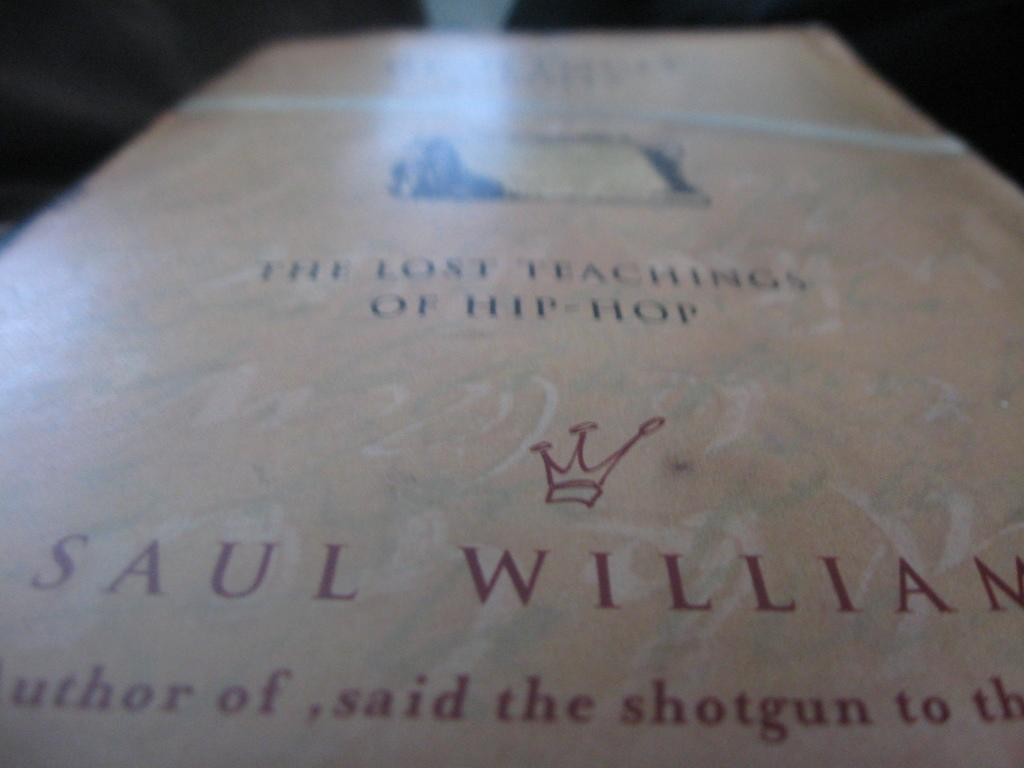<image>
Summarize the visual content of the image. The Lost Teachings of Hip-Hop book by Saul Williams with a light pink and green marble cover. 